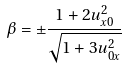Convert formula to latex. <formula><loc_0><loc_0><loc_500><loc_500>\beta = \pm \frac { 1 + 2 u _ { x 0 } ^ { 2 } } { \sqrt { 1 + 3 u _ { 0 x } ^ { 2 } } }</formula> 